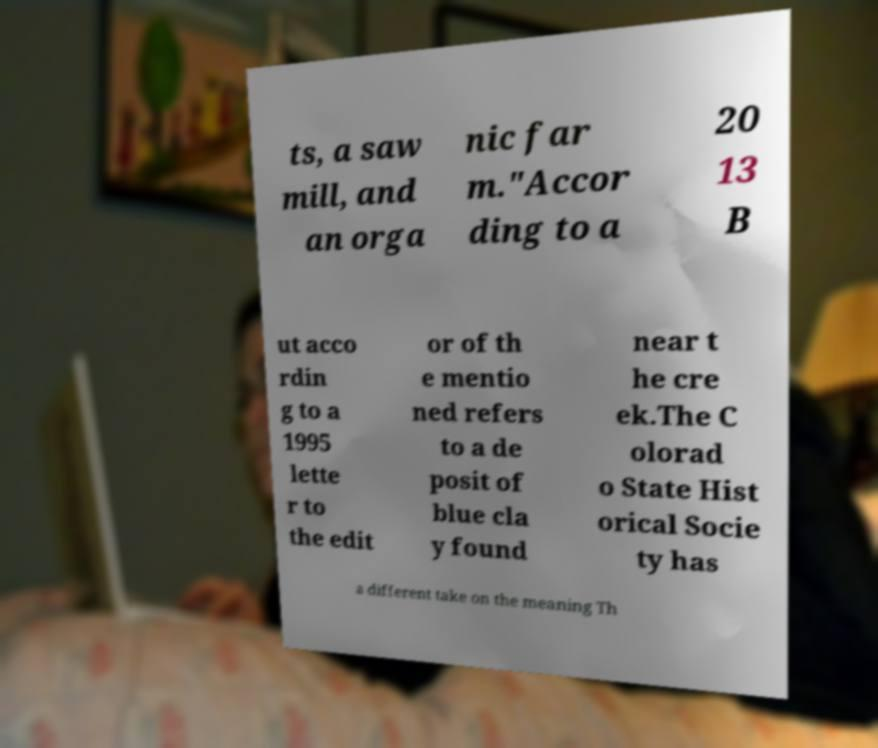Can you read and provide the text displayed in the image?This photo seems to have some interesting text. Can you extract and type it out for me? ts, a saw mill, and an orga nic far m."Accor ding to a 20 13 B ut acco rdin g to a 1995 lette r to the edit or of th e mentio ned refers to a de posit of blue cla y found near t he cre ek.The C olorad o State Hist orical Socie ty has a different take on the meaning Th 